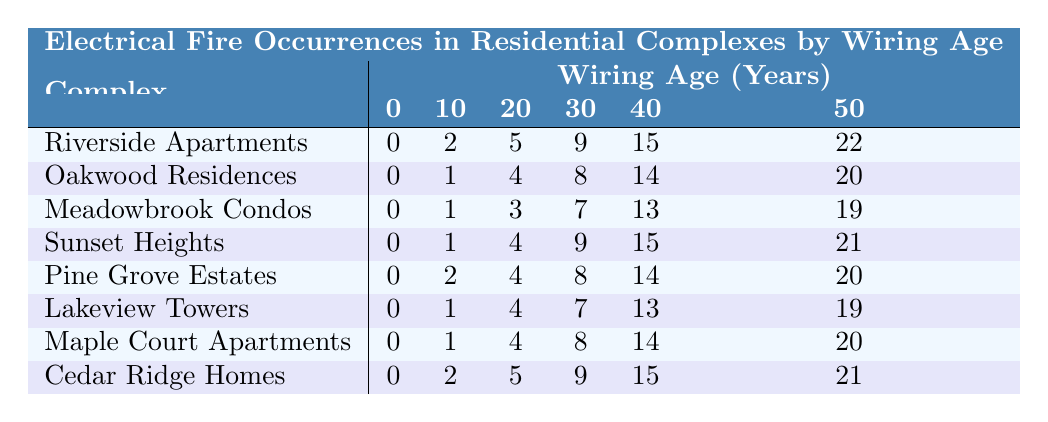What is the total number of fires in Riverside Apartments after 50 years? The table shows that Riverside Apartments had 22 fire occurrences after 50 years.
Answer: 22 Which complex had the highest number of fires at 30 years? By comparing the values in the 30-year column, Riverside Apartments has 9 fires at this age, which is higher than the others.
Answer: Riverside Apartments What is the difference in the number of fires between Oakwood Residences at 20 years and Meadowbrook Condos at 20 years? Oakwood Residences had 4 fires while Meadowbrook Condos had 3 fires at 20 years. The difference is 4 - 3 = 1.
Answer: 1 Are there any complexes that had fires at 0 years? Looking at the table, all listed complexes had 0 fires at 0 years, confirming this is true.
Answer: Yes Which complex has consistently the lowest amount of fires recorded across all ages? By observing each row, Oakwood Residences has the lowest values compared to others in all age categories considered.
Answer: Oakwood Residences What is the total number of fires in Lakeview Towers over the 50-year period? Adding the fires at each age: 0 + 1 + 4 + 7 + 13 + 19 gives a total of 44 fires during the 50 years.
Answer: 44 How many more fires did Sunset Heights have at 40 years than Cedar Ridge Homes at 40 years? Sunset Heights had 15 fires and Cedar Ridge Homes had 15 fires at 40 years, hence there is no difference: 15 - 15 = 0.
Answer: 0 What is the average number of fires for Pine Grove Estates across all time frames? Pine Grove Estates recorded fires as follows: 0, 2, 4, 8, 14, and 20. Summing these gives 48. Dividing by 6 gives an average of 48/6 = 8.
Answer: 8 Which complex saw a total of exactly 20 fires after 50 years? By examining the last column, it is clear that both Oakwood Residences and Pine Grove Estates both resulted in 20 fires over the 50 years.
Answer: Oakwood Residences and Pine Grove Estates What can be inferred about fire occurrences in relation to wiring age for the complexes listed? Generally, as the wiring age increases, the number of fires tends to rise for most complexes, suggesting a correlation between aging wiring and fire risk.
Answer: Increased risk with age 